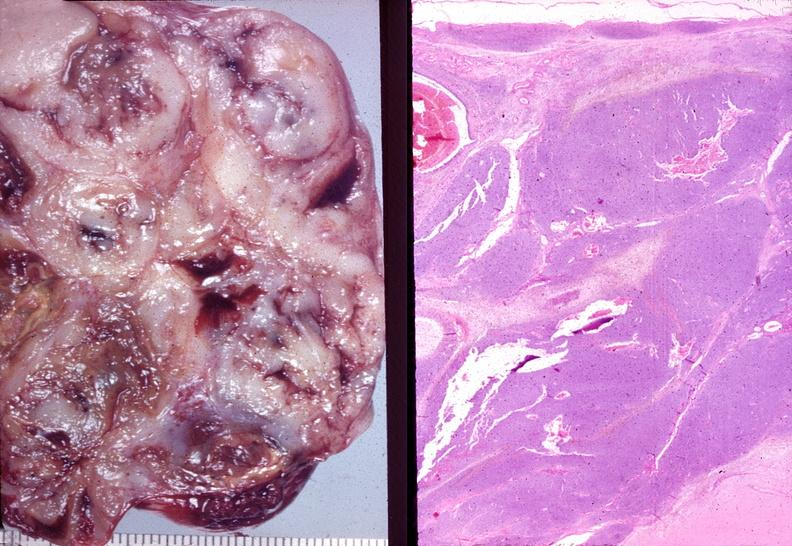what does this image show?
Answer the question using a single word or phrase. Ovary 